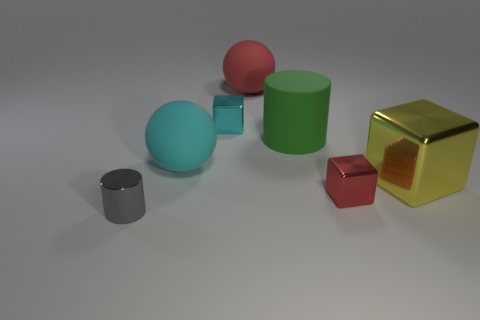Subtract all cyan blocks. How many blocks are left? 2 Add 1 small cyan things. How many objects exist? 8 Subtract all balls. How many objects are left? 5 Subtract all big cyan things. Subtract all small objects. How many objects are left? 3 Add 4 green cylinders. How many green cylinders are left? 5 Add 2 cyan objects. How many cyan objects exist? 4 Subtract 1 yellow cubes. How many objects are left? 6 